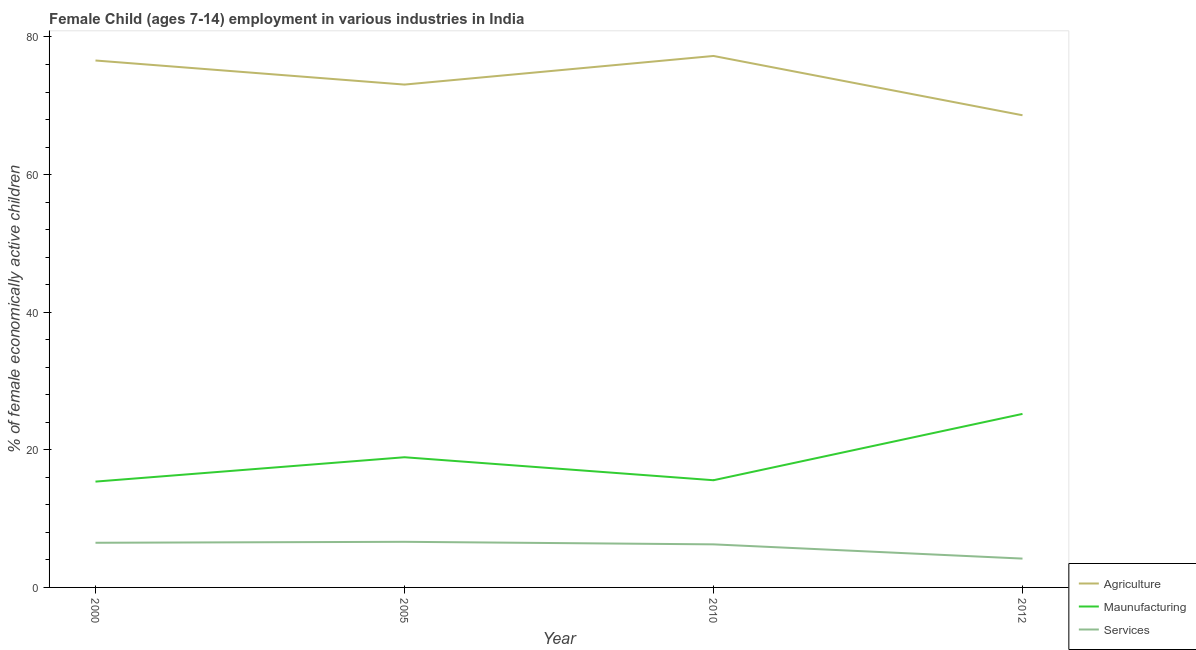How many different coloured lines are there?
Provide a short and direct response. 3. Does the line corresponding to percentage of economically active children in services intersect with the line corresponding to percentage of economically active children in agriculture?
Offer a terse response. No. Is the number of lines equal to the number of legend labels?
Give a very brief answer. Yes. What is the percentage of economically active children in services in 2012?
Offer a terse response. 4.19. Across all years, what is the maximum percentage of economically active children in agriculture?
Your response must be concise. 77.24. Across all years, what is the minimum percentage of economically active children in services?
Offer a very short reply. 4.19. In which year was the percentage of economically active children in agriculture maximum?
Your answer should be compact. 2010. What is the total percentage of economically active children in manufacturing in the graph?
Offer a terse response. 75.1. What is the difference between the percentage of economically active children in services in 2005 and that in 2010?
Keep it short and to the point. 0.37. What is the difference between the percentage of economically active children in services in 2010 and the percentage of economically active children in manufacturing in 2005?
Offer a terse response. -12.66. What is the average percentage of economically active children in services per year?
Your answer should be very brief. 5.89. In the year 2010, what is the difference between the percentage of economically active children in services and percentage of economically active children in manufacturing?
Your response must be concise. -9.32. What is the ratio of the percentage of economically active children in agriculture in 2010 to that in 2012?
Offer a very short reply. 1.13. Is the percentage of economically active children in services in 2000 less than that in 2005?
Keep it short and to the point. Yes. Is the difference between the percentage of economically active children in services in 2005 and 2010 greater than the difference between the percentage of economically active children in agriculture in 2005 and 2010?
Make the answer very short. Yes. What is the difference between the highest and the second highest percentage of economically active children in services?
Provide a succinct answer. 0.14. What is the difference between the highest and the lowest percentage of economically active children in manufacturing?
Ensure brevity in your answer.  9.84. In how many years, is the percentage of economically active children in agriculture greater than the average percentage of economically active children in agriculture taken over all years?
Give a very brief answer. 2. Is the sum of the percentage of economically active children in manufacturing in 2000 and 2010 greater than the maximum percentage of economically active children in services across all years?
Give a very brief answer. Yes. Does the percentage of economically active children in agriculture monotonically increase over the years?
Offer a very short reply. No. Is the percentage of economically active children in services strictly greater than the percentage of economically active children in manufacturing over the years?
Offer a very short reply. No. How many years are there in the graph?
Give a very brief answer. 4. What is the difference between two consecutive major ticks on the Y-axis?
Ensure brevity in your answer.  20. Are the values on the major ticks of Y-axis written in scientific E-notation?
Keep it short and to the point. No. Where does the legend appear in the graph?
Your response must be concise. Bottom right. What is the title of the graph?
Your response must be concise. Female Child (ages 7-14) employment in various industries in India. Does "Agricultural Nitrous Oxide" appear as one of the legend labels in the graph?
Offer a very short reply. No. What is the label or title of the Y-axis?
Offer a very short reply. % of female economically active children. What is the % of female economically active children in Agriculture in 2000?
Your answer should be compact. 76.58. What is the % of female economically active children in Maunufacturing in 2000?
Give a very brief answer. 15.38. What is the % of female economically active children in Services in 2000?
Offer a very short reply. 6.49. What is the % of female economically active children of Agriculture in 2005?
Keep it short and to the point. 73.08. What is the % of female economically active children of Maunufacturing in 2005?
Offer a very short reply. 18.92. What is the % of female economically active children of Services in 2005?
Your answer should be compact. 6.63. What is the % of female economically active children of Agriculture in 2010?
Ensure brevity in your answer.  77.24. What is the % of female economically active children in Maunufacturing in 2010?
Make the answer very short. 15.58. What is the % of female economically active children of Services in 2010?
Keep it short and to the point. 6.26. What is the % of female economically active children in Agriculture in 2012?
Give a very brief answer. 68.62. What is the % of female economically active children in Maunufacturing in 2012?
Provide a short and direct response. 25.22. What is the % of female economically active children of Services in 2012?
Provide a short and direct response. 4.19. Across all years, what is the maximum % of female economically active children of Agriculture?
Ensure brevity in your answer.  77.24. Across all years, what is the maximum % of female economically active children of Maunufacturing?
Make the answer very short. 25.22. Across all years, what is the maximum % of female economically active children in Services?
Provide a succinct answer. 6.63. Across all years, what is the minimum % of female economically active children of Agriculture?
Provide a short and direct response. 68.62. Across all years, what is the minimum % of female economically active children of Maunufacturing?
Give a very brief answer. 15.38. Across all years, what is the minimum % of female economically active children of Services?
Make the answer very short. 4.19. What is the total % of female economically active children of Agriculture in the graph?
Offer a very short reply. 295.52. What is the total % of female economically active children of Maunufacturing in the graph?
Ensure brevity in your answer.  75.1. What is the total % of female economically active children in Services in the graph?
Provide a short and direct response. 23.57. What is the difference between the % of female economically active children in Maunufacturing in 2000 and that in 2005?
Ensure brevity in your answer.  -3.54. What is the difference between the % of female economically active children in Services in 2000 and that in 2005?
Make the answer very short. -0.14. What is the difference between the % of female economically active children in Agriculture in 2000 and that in 2010?
Ensure brevity in your answer.  -0.66. What is the difference between the % of female economically active children of Services in 2000 and that in 2010?
Ensure brevity in your answer.  0.23. What is the difference between the % of female economically active children of Agriculture in 2000 and that in 2012?
Keep it short and to the point. 7.96. What is the difference between the % of female economically active children of Maunufacturing in 2000 and that in 2012?
Your answer should be compact. -9.84. What is the difference between the % of female economically active children in Services in 2000 and that in 2012?
Offer a terse response. 2.3. What is the difference between the % of female economically active children of Agriculture in 2005 and that in 2010?
Offer a very short reply. -4.16. What is the difference between the % of female economically active children in Maunufacturing in 2005 and that in 2010?
Keep it short and to the point. 3.34. What is the difference between the % of female economically active children in Services in 2005 and that in 2010?
Make the answer very short. 0.37. What is the difference between the % of female economically active children of Agriculture in 2005 and that in 2012?
Your answer should be very brief. 4.46. What is the difference between the % of female economically active children of Maunufacturing in 2005 and that in 2012?
Offer a very short reply. -6.3. What is the difference between the % of female economically active children of Services in 2005 and that in 2012?
Your answer should be compact. 2.44. What is the difference between the % of female economically active children in Agriculture in 2010 and that in 2012?
Provide a short and direct response. 8.62. What is the difference between the % of female economically active children in Maunufacturing in 2010 and that in 2012?
Give a very brief answer. -9.64. What is the difference between the % of female economically active children in Services in 2010 and that in 2012?
Give a very brief answer. 2.07. What is the difference between the % of female economically active children in Agriculture in 2000 and the % of female economically active children in Maunufacturing in 2005?
Offer a terse response. 57.66. What is the difference between the % of female economically active children in Agriculture in 2000 and the % of female economically active children in Services in 2005?
Your answer should be compact. 69.95. What is the difference between the % of female economically active children of Maunufacturing in 2000 and the % of female economically active children of Services in 2005?
Make the answer very short. 8.75. What is the difference between the % of female economically active children of Agriculture in 2000 and the % of female economically active children of Maunufacturing in 2010?
Offer a terse response. 61. What is the difference between the % of female economically active children in Agriculture in 2000 and the % of female economically active children in Services in 2010?
Offer a terse response. 70.32. What is the difference between the % of female economically active children in Maunufacturing in 2000 and the % of female economically active children in Services in 2010?
Your answer should be very brief. 9.12. What is the difference between the % of female economically active children of Agriculture in 2000 and the % of female economically active children of Maunufacturing in 2012?
Your answer should be compact. 51.36. What is the difference between the % of female economically active children of Agriculture in 2000 and the % of female economically active children of Services in 2012?
Provide a short and direct response. 72.39. What is the difference between the % of female economically active children in Maunufacturing in 2000 and the % of female economically active children in Services in 2012?
Provide a succinct answer. 11.19. What is the difference between the % of female economically active children of Agriculture in 2005 and the % of female economically active children of Maunufacturing in 2010?
Ensure brevity in your answer.  57.5. What is the difference between the % of female economically active children in Agriculture in 2005 and the % of female economically active children in Services in 2010?
Your response must be concise. 66.82. What is the difference between the % of female economically active children in Maunufacturing in 2005 and the % of female economically active children in Services in 2010?
Your answer should be very brief. 12.66. What is the difference between the % of female economically active children of Agriculture in 2005 and the % of female economically active children of Maunufacturing in 2012?
Your answer should be compact. 47.86. What is the difference between the % of female economically active children of Agriculture in 2005 and the % of female economically active children of Services in 2012?
Ensure brevity in your answer.  68.89. What is the difference between the % of female economically active children of Maunufacturing in 2005 and the % of female economically active children of Services in 2012?
Offer a very short reply. 14.73. What is the difference between the % of female economically active children of Agriculture in 2010 and the % of female economically active children of Maunufacturing in 2012?
Offer a very short reply. 52.02. What is the difference between the % of female economically active children in Agriculture in 2010 and the % of female economically active children in Services in 2012?
Offer a very short reply. 73.05. What is the difference between the % of female economically active children in Maunufacturing in 2010 and the % of female economically active children in Services in 2012?
Make the answer very short. 11.39. What is the average % of female economically active children in Agriculture per year?
Offer a very short reply. 73.88. What is the average % of female economically active children in Maunufacturing per year?
Give a very brief answer. 18.77. What is the average % of female economically active children in Services per year?
Make the answer very short. 5.89. In the year 2000, what is the difference between the % of female economically active children of Agriculture and % of female economically active children of Maunufacturing?
Your answer should be compact. 61.2. In the year 2000, what is the difference between the % of female economically active children in Agriculture and % of female economically active children in Services?
Your answer should be compact. 70.09. In the year 2000, what is the difference between the % of female economically active children of Maunufacturing and % of female economically active children of Services?
Provide a succinct answer. 8.89. In the year 2005, what is the difference between the % of female economically active children in Agriculture and % of female economically active children in Maunufacturing?
Keep it short and to the point. 54.16. In the year 2005, what is the difference between the % of female economically active children in Agriculture and % of female economically active children in Services?
Provide a succinct answer. 66.45. In the year 2005, what is the difference between the % of female economically active children in Maunufacturing and % of female economically active children in Services?
Your answer should be very brief. 12.29. In the year 2010, what is the difference between the % of female economically active children in Agriculture and % of female economically active children in Maunufacturing?
Your answer should be compact. 61.66. In the year 2010, what is the difference between the % of female economically active children of Agriculture and % of female economically active children of Services?
Offer a terse response. 70.98. In the year 2010, what is the difference between the % of female economically active children in Maunufacturing and % of female economically active children in Services?
Provide a short and direct response. 9.32. In the year 2012, what is the difference between the % of female economically active children of Agriculture and % of female economically active children of Maunufacturing?
Give a very brief answer. 43.4. In the year 2012, what is the difference between the % of female economically active children of Agriculture and % of female economically active children of Services?
Make the answer very short. 64.43. In the year 2012, what is the difference between the % of female economically active children in Maunufacturing and % of female economically active children in Services?
Offer a very short reply. 21.03. What is the ratio of the % of female economically active children of Agriculture in 2000 to that in 2005?
Provide a succinct answer. 1.05. What is the ratio of the % of female economically active children of Maunufacturing in 2000 to that in 2005?
Provide a short and direct response. 0.81. What is the ratio of the % of female economically active children of Services in 2000 to that in 2005?
Give a very brief answer. 0.98. What is the ratio of the % of female economically active children of Maunufacturing in 2000 to that in 2010?
Make the answer very short. 0.99. What is the ratio of the % of female economically active children of Services in 2000 to that in 2010?
Make the answer very short. 1.04. What is the ratio of the % of female economically active children in Agriculture in 2000 to that in 2012?
Offer a very short reply. 1.12. What is the ratio of the % of female economically active children in Maunufacturing in 2000 to that in 2012?
Offer a terse response. 0.61. What is the ratio of the % of female economically active children in Services in 2000 to that in 2012?
Make the answer very short. 1.55. What is the ratio of the % of female economically active children in Agriculture in 2005 to that in 2010?
Your answer should be compact. 0.95. What is the ratio of the % of female economically active children in Maunufacturing in 2005 to that in 2010?
Keep it short and to the point. 1.21. What is the ratio of the % of female economically active children in Services in 2005 to that in 2010?
Your response must be concise. 1.06. What is the ratio of the % of female economically active children in Agriculture in 2005 to that in 2012?
Provide a short and direct response. 1.06. What is the ratio of the % of female economically active children of Maunufacturing in 2005 to that in 2012?
Your response must be concise. 0.75. What is the ratio of the % of female economically active children in Services in 2005 to that in 2012?
Provide a short and direct response. 1.58. What is the ratio of the % of female economically active children of Agriculture in 2010 to that in 2012?
Keep it short and to the point. 1.13. What is the ratio of the % of female economically active children in Maunufacturing in 2010 to that in 2012?
Your answer should be very brief. 0.62. What is the ratio of the % of female economically active children in Services in 2010 to that in 2012?
Your answer should be compact. 1.49. What is the difference between the highest and the second highest % of female economically active children of Agriculture?
Your answer should be very brief. 0.66. What is the difference between the highest and the second highest % of female economically active children in Services?
Offer a terse response. 0.14. What is the difference between the highest and the lowest % of female economically active children in Agriculture?
Provide a short and direct response. 8.62. What is the difference between the highest and the lowest % of female economically active children in Maunufacturing?
Ensure brevity in your answer.  9.84. What is the difference between the highest and the lowest % of female economically active children in Services?
Your response must be concise. 2.44. 